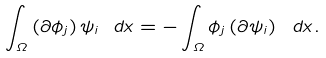<formula> <loc_0><loc_0><loc_500><loc_500>\int _ { \Omega } \left ( \partial \phi _ { j } \right ) \psi _ { i } \ d x = - \int _ { \Omega } \phi _ { j } \left ( \partial \psi _ { i } \right ) \ d x .</formula> 